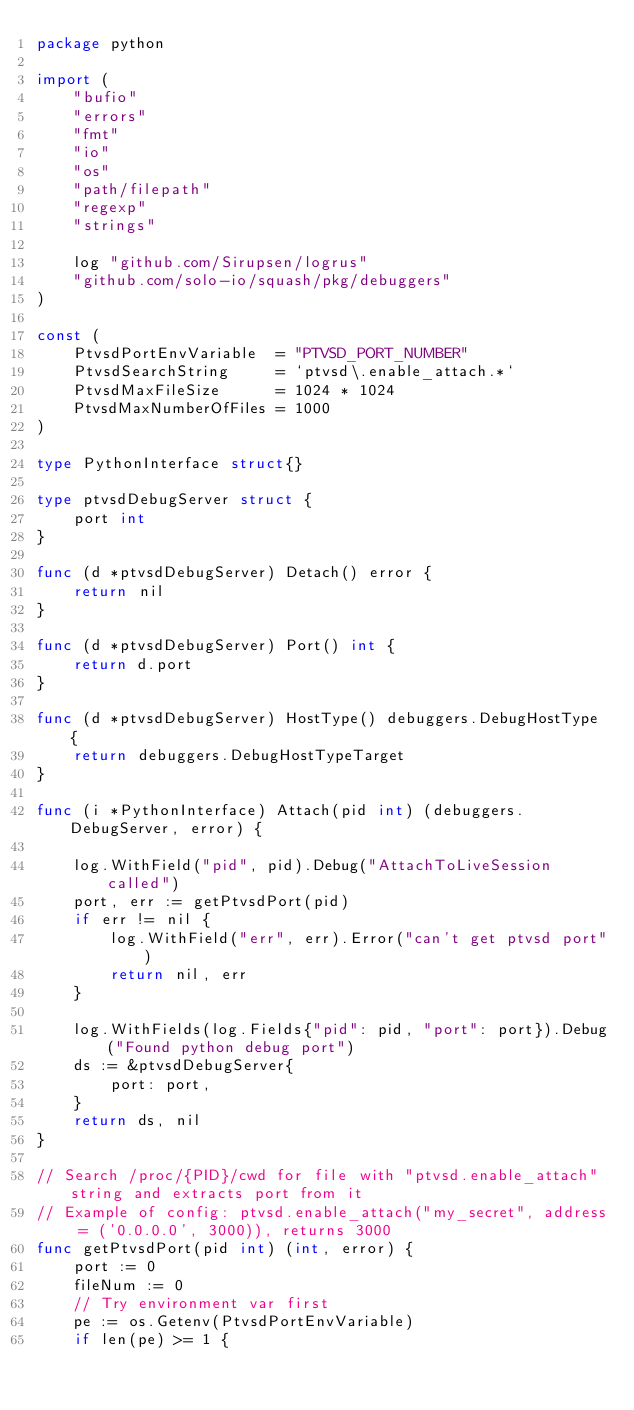Convert code to text. <code><loc_0><loc_0><loc_500><loc_500><_Go_>package python

import (
	"bufio"
	"errors"
	"fmt"
	"io"
	"os"
	"path/filepath"
	"regexp"
	"strings"

	log "github.com/Sirupsen/logrus"
	"github.com/solo-io/squash/pkg/debuggers"
)

const (
	PtvsdPortEnvVariable  = "PTVSD_PORT_NUMBER"
	PtvsdSearchString     = `ptvsd\.enable_attach.*`
	PtvsdMaxFileSize      = 1024 * 1024
	PtvsdMaxNumberOfFiles = 1000
)

type PythonInterface struct{}

type ptvsdDebugServer struct {
	port int
}

func (d *ptvsdDebugServer) Detach() error {
	return nil
}

func (d *ptvsdDebugServer) Port() int {
	return d.port
}

func (d *ptvsdDebugServer) HostType() debuggers.DebugHostType {
	return debuggers.DebugHostTypeTarget
}

func (i *PythonInterface) Attach(pid int) (debuggers.DebugServer, error) {

	log.WithField("pid", pid).Debug("AttachToLiveSession called")
	port, err := getPtvsdPort(pid)
	if err != nil {
		log.WithField("err", err).Error("can't get ptvsd port")
		return nil, err
	}

	log.WithFields(log.Fields{"pid": pid, "port": port}).Debug("Found python debug port")
	ds := &ptvsdDebugServer{
		port: port,
	}
	return ds, nil
}

// Search /proc/{PID}/cwd for file with "ptvsd.enable_attach" string and extracts port from it
// Example of config: ptvsd.enable_attach("my_secret", address = ('0.0.0.0', 3000)), returns 3000
func getPtvsdPort(pid int) (int, error) {
	port := 0
	fileNum := 0
	// Try environment var first
	pe := os.Getenv(PtvsdPortEnvVariable)
	if len(pe) >= 1 {</code> 